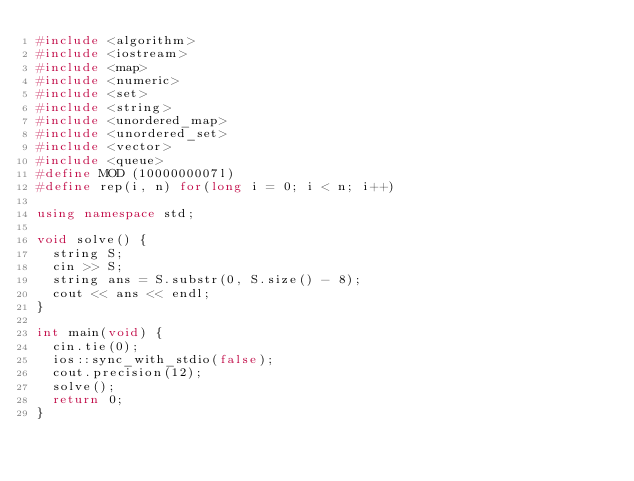<code> <loc_0><loc_0><loc_500><loc_500><_C++_>#include <algorithm>
#include <iostream>
#include <map>
#include <numeric>
#include <set>
#include <string>
#include <unordered_map>
#include <unordered_set>
#include <vector>
#include <queue>
#define MOD (1000000007l)
#define rep(i, n) for(long i = 0; i < n; i++)

using namespace std;

void solve() {
  string S;
  cin >> S;
  string ans = S.substr(0, S.size() - 8);
  cout << ans << endl;
}

int main(void) {
  cin.tie(0);
  ios::sync_with_stdio(false);
  cout.precision(12);
  solve();
  return 0;
}
</code> 